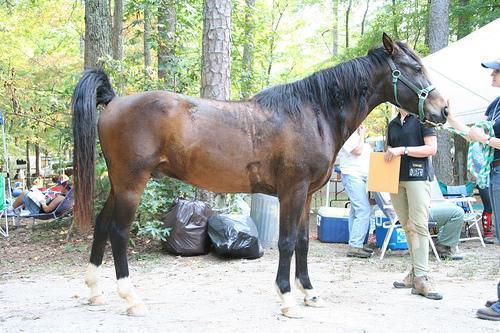How many horse are seen?
Give a very brief answer. 1. How many people are wearing blue jeans?
Give a very brief answer. 2. 